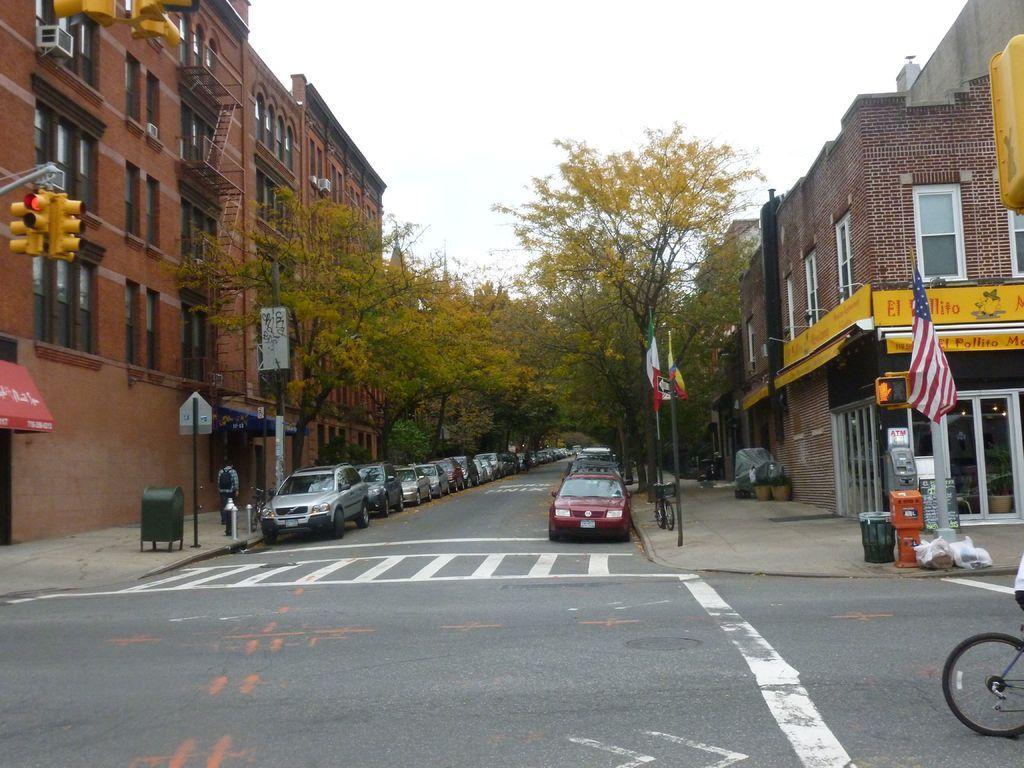Can you describe this image briefly? In this image, we can see so many vehicles are parked on the road. On the road, we can see few lines. Here there are so many buildings, trees, poles, walls, windows, stairs, traffic signals, banners, boards and walkways. Here we can see a person is standing on the walkway. Background there is a sky. 